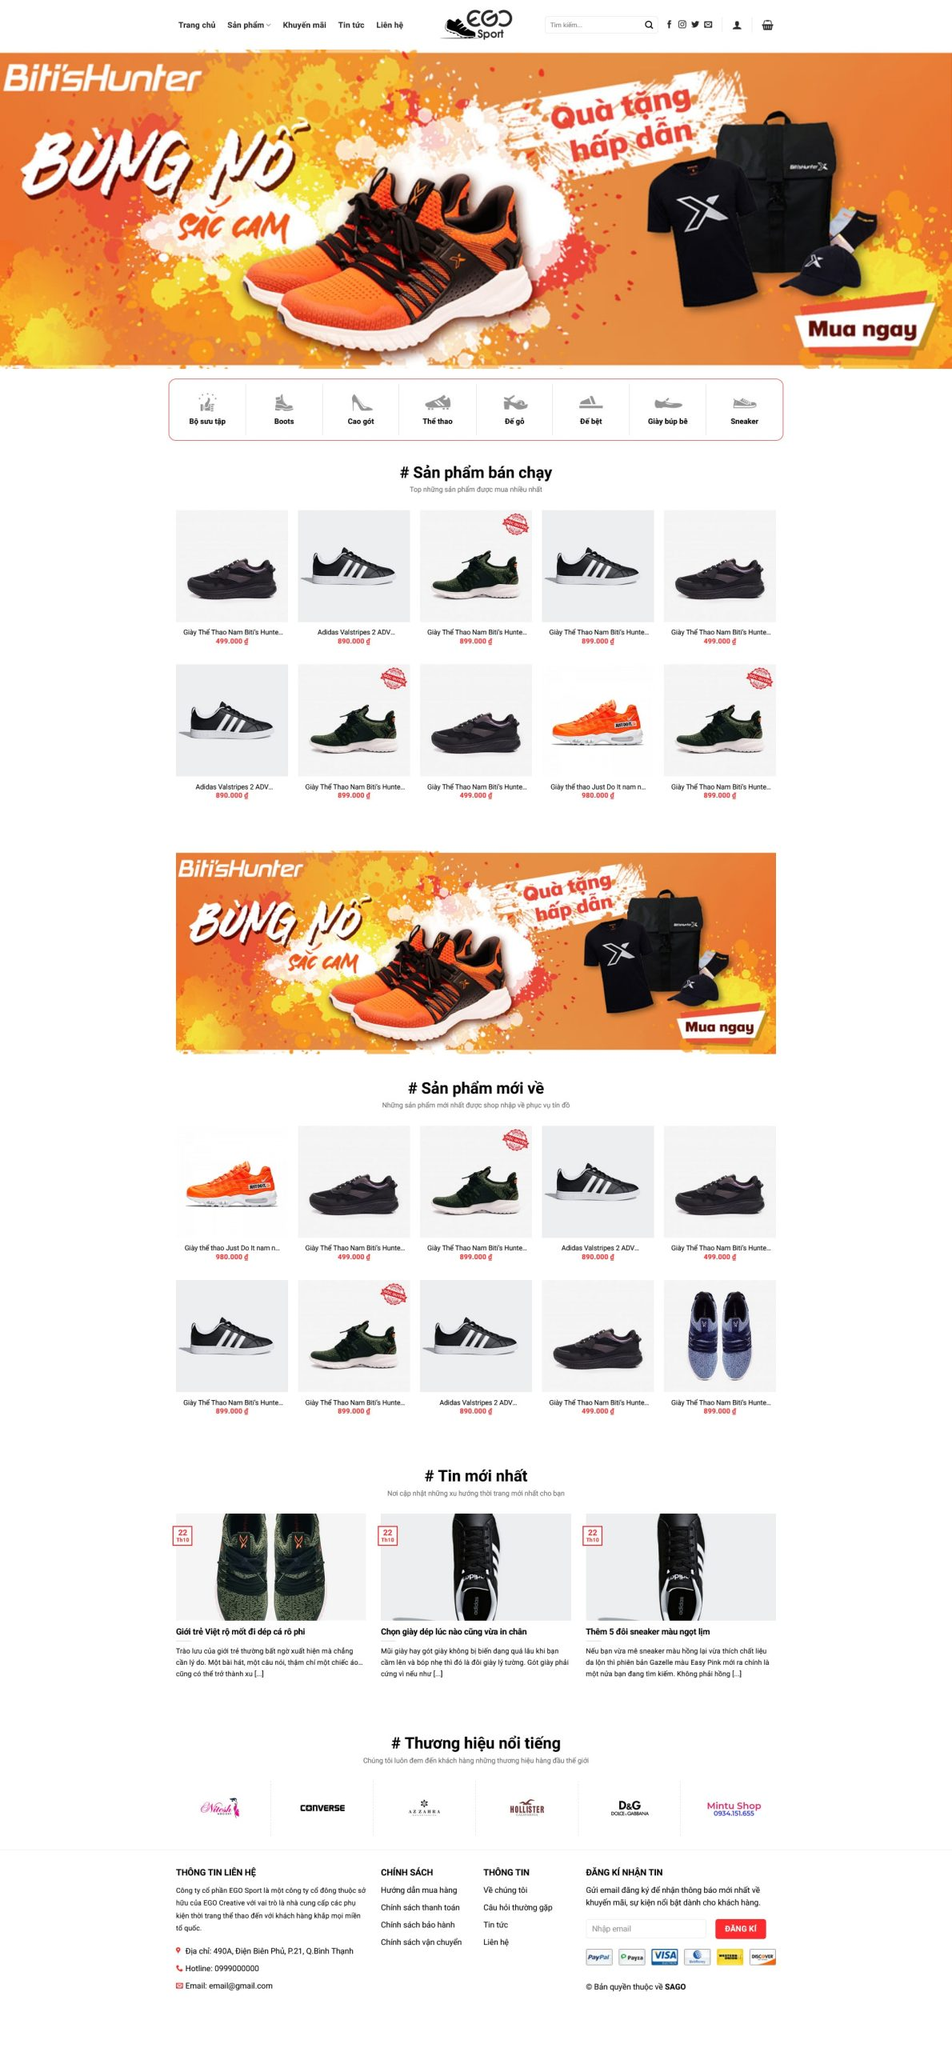Liệt kê 5 ngành nghề, lĩnh vực phù hợp với website này, phân cách các màu sắc bằng dấu phẩy. Chỉ trả về kết quả, phân cách bằng dấy phẩy
 Thể thao, Giày dép, Thời trang, Bán lẻ, Thương mại điện tử 